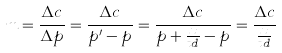Convert formula to latex. <formula><loc_0><loc_0><loc_500><loc_500>m = \frac { \Delta c } { \Delta p } = \frac { \Delta c } { p ^ { \prime } - p } = \frac { \Delta c } { p + \frac { x } { t d } - p } = \frac { \Delta c } { \frac { x } { t d } }</formula> 